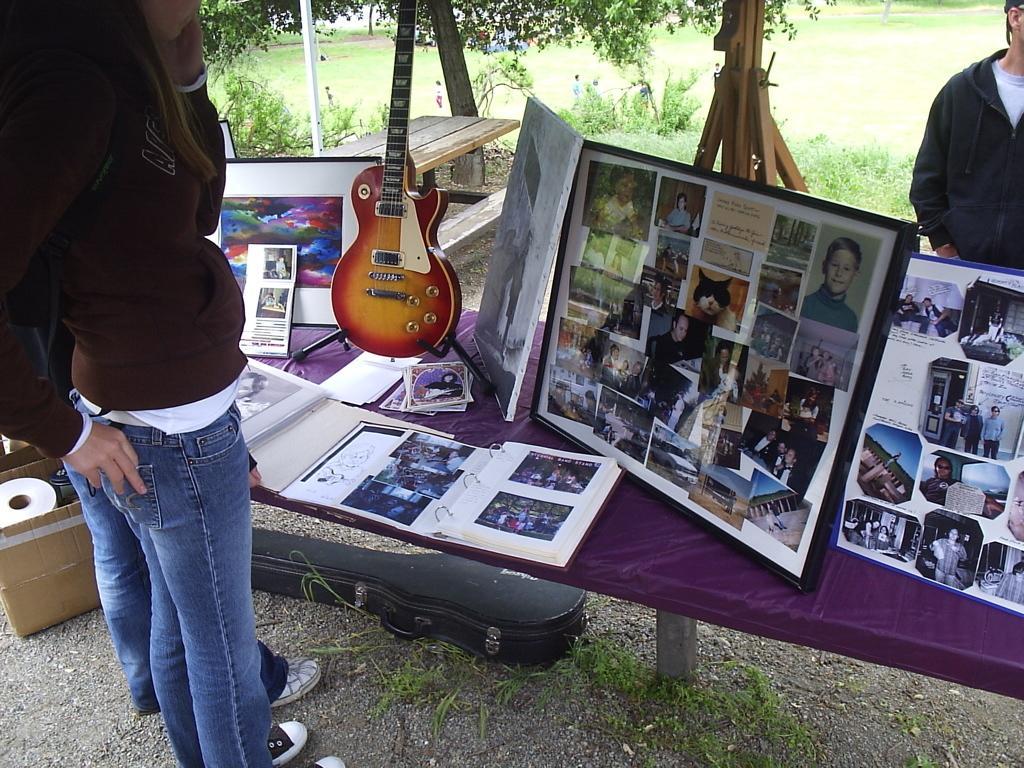In one or two sentences, can you explain what this image depicts? In this picture there are many photo frames kept on the table. A guitar box is on the floor ,there are three people in the frame and a guitar is kept on the table. In the background ,there are trees. 